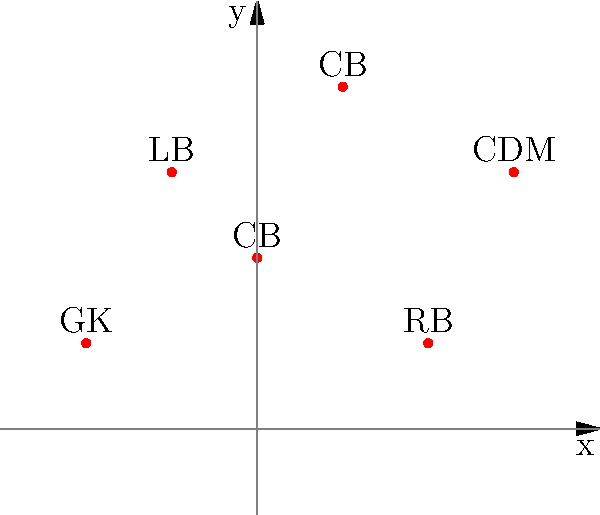In a soccer formation analysis, player positions are plotted on a coordinate plane. The goalkeeper (GK) is at (-2, 1), left-back (LB) at (-1, 3), center-backs (CB) at (0, 2) and (1, 4), right-back (RB) at (2, 1), and central defensive midfielder (CDM) at (3, 3). What is the average x-coordinate of the two center-backs, and what does this value represent in terms of field position? To solve this problem, we'll follow these steps:

1. Identify the x-coordinates of the two center-backs (CB):
   - First CB: x = 0
   - Second CB: x = 1

2. Calculate the average x-coordinate:
   $$ \text{Average} = \frac{\text{Sum of values}}{\text{Number of values}} $$
   $$ \text{Average x-coordinate} = \frac{0 + 1}{2} = \frac{1}{2} = 0.5 $$

3. Interpret the result:
   - The x-axis represents the width of the soccer field.
   - The value 0 would represent the exact center of the field width-wise.
   - A positive value (0.5) indicates a position slightly to the right of the center.

Therefore, the average x-coordinate of 0.5 represents that the center-backs are positioned slightly to the right of the center of the field. This could indicate a tactical decision to shift the defense slightly towards the right side, possibly to counter the opponent's attacking strength or to support the team's own offensive strategy on that side.
Answer: 0.5; slightly right of center field 